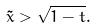<formula> <loc_0><loc_0><loc_500><loc_500>\tilde { x } > \sqrt { 1 - t } .</formula> 